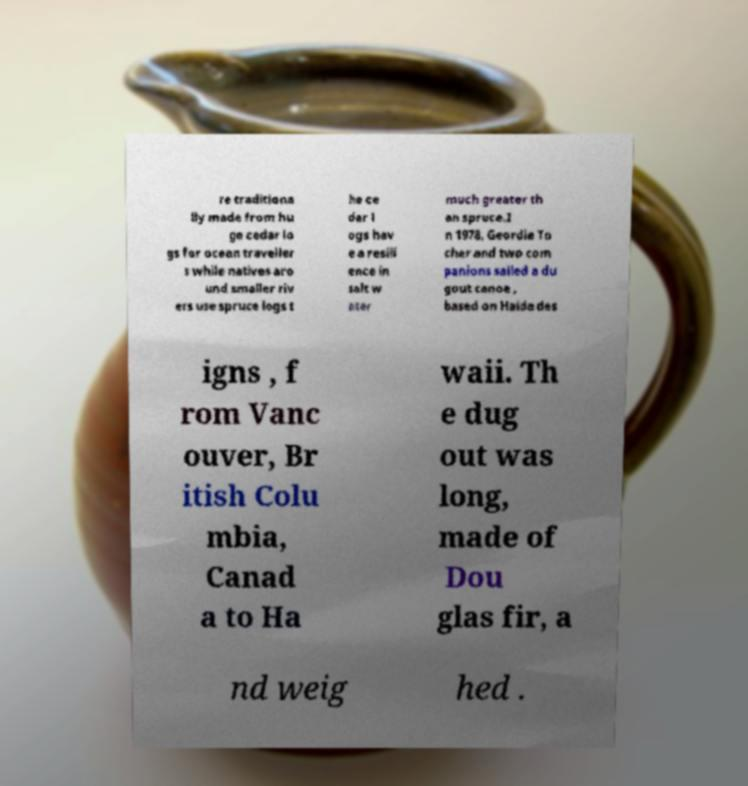Can you read and provide the text displayed in the image?This photo seems to have some interesting text. Can you extract and type it out for me? re traditiona lly made from hu ge cedar lo gs for ocean traveller s while natives aro und smaller riv ers use spruce logs t he ce dar l ogs hav e a resili ence in salt w ater much greater th an spruce.I n 1978, Geordie To cher and two com panions sailed a du gout canoe , based on Haida des igns , f rom Vanc ouver, Br itish Colu mbia, Canad a to Ha waii. Th e dug out was long, made of Dou glas fir, a nd weig hed . 